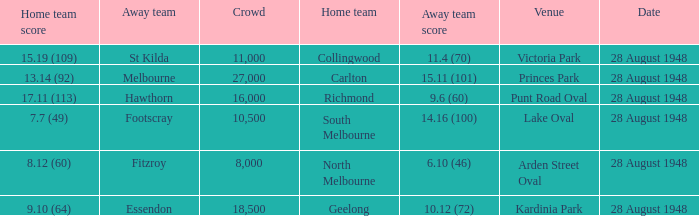What home team has a team score of 8.12 (60)? North Melbourne. Help me parse the entirety of this table. {'header': ['Home team score', 'Away team', 'Crowd', 'Home team', 'Away team score', 'Venue', 'Date'], 'rows': [['15.19 (109)', 'St Kilda', '11,000', 'Collingwood', '11.4 (70)', 'Victoria Park', '28 August 1948'], ['13.14 (92)', 'Melbourne', '27,000', 'Carlton', '15.11 (101)', 'Princes Park', '28 August 1948'], ['17.11 (113)', 'Hawthorn', '16,000', 'Richmond', '9.6 (60)', 'Punt Road Oval', '28 August 1948'], ['7.7 (49)', 'Footscray', '10,500', 'South Melbourne', '14.16 (100)', 'Lake Oval', '28 August 1948'], ['8.12 (60)', 'Fitzroy', '8,000', 'North Melbourne', '6.10 (46)', 'Arden Street Oval', '28 August 1948'], ['9.10 (64)', 'Essendon', '18,500', 'Geelong', '10.12 (72)', 'Kardinia Park', '28 August 1948']]} 